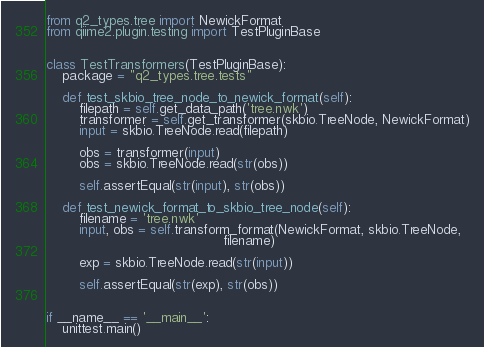<code> <loc_0><loc_0><loc_500><loc_500><_Python_>
from q2_types.tree import NewickFormat
from qiime2.plugin.testing import TestPluginBase


class TestTransformers(TestPluginBase):
    package = "q2_types.tree.tests"

    def test_skbio_tree_node_to_newick_format(self):
        filepath = self.get_data_path('tree.nwk')
        transformer = self.get_transformer(skbio.TreeNode, NewickFormat)
        input = skbio.TreeNode.read(filepath)

        obs = transformer(input)
        obs = skbio.TreeNode.read(str(obs))

        self.assertEqual(str(input), str(obs))

    def test_newick_format_to_skbio_tree_node(self):
        filename = 'tree.nwk'
        input, obs = self.transform_format(NewickFormat, skbio.TreeNode,
                                           filename)

        exp = skbio.TreeNode.read(str(input))

        self.assertEqual(str(exp), str(obs))


if __name__ == '__main__':
    unittest.main()
</code> 